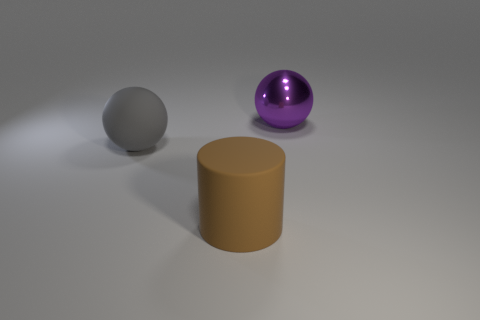Add 3 red rubber things. How many objects exist? 6 Subtract all balls. How many objects are left? 1 Subtract all large matte cylinders. Subtract all rubber objects. How many objects are left? 0 Add 3 big purple metal objects. How many big purple metal objects are left? 4 Add 3 tiny blue matte things. How many tiny blue matte things exist? 3 Subtract 0 brown cubes. How many objects are left? 3 